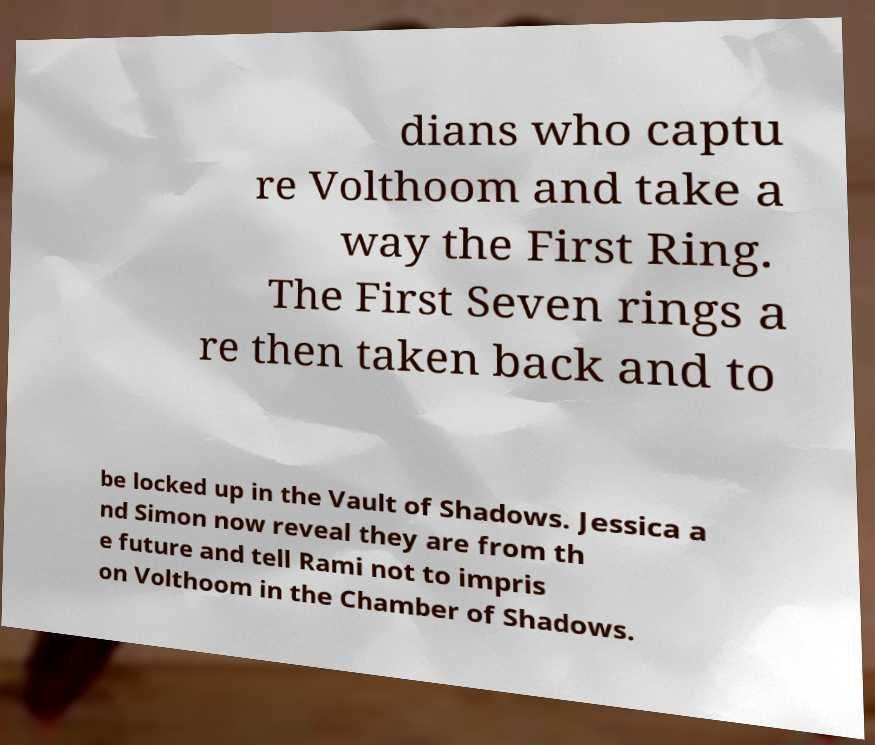Can you accurately transcribe the text from the provided image for me? dians who captu re Volthoom and take a way the First Ring. The First Seven rings a re then taken back and to be locked up in the Vault of Shadows. Jessica a nd Simon now reveal they are from th e future and tell Rami not to impris on Volthoom in the Chamber of Shadows. 